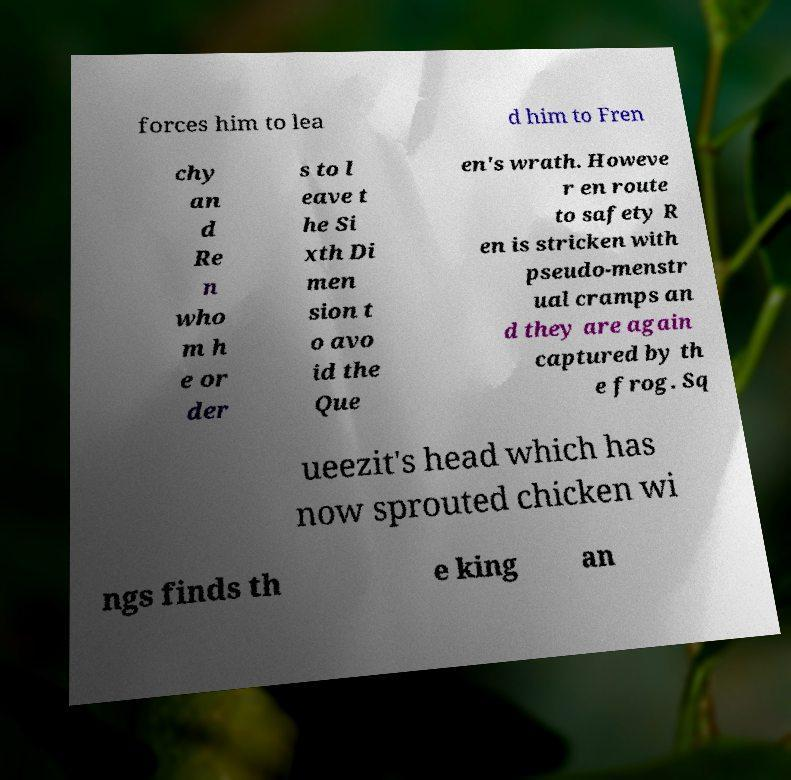What messages or text are displayed in this image? I need them in a readable, typed format. forces him to lea d him to Fren chy an d Re n who m h e or der s to l eave t he Si xth Di men sion t o avo id the Que en's wrath. Howeve r en route to safety R en is stricken with pseudo-menstr ual cramps an d they are again captured by th e frog. Sq ueezit's head which has now sprouted chicken wi ngs finds th e king an 